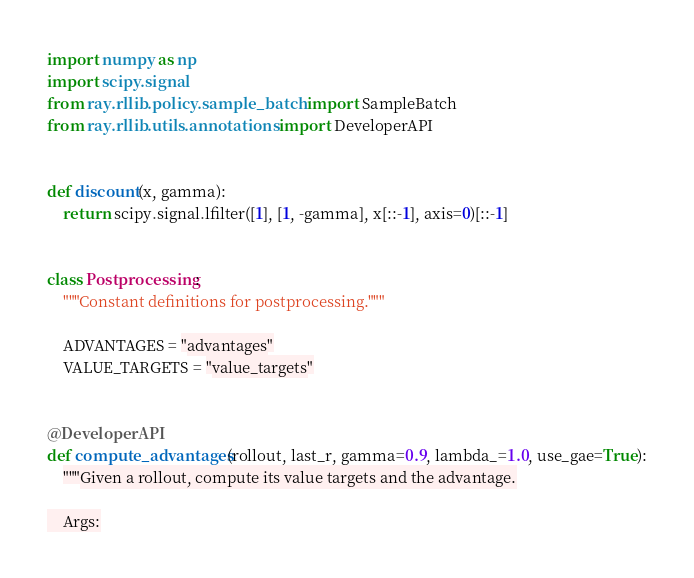<code> <loc_0><loc_0><loc_500><loc_500><_Python_>import numpy as np
import scipy.signal
from ray.rllib.policy.sample_batch import SampleBatch
from ray.rllib.utils.annotations import DeveloperAPI


def discount(x, gamma):
    return scipy.signal.lfilter([1], [1, -gamma], x[::-1], axis=0)[::-1]


class Postprocessing:
    """Constant definitions for postprocessing."""

    ADVANTAGES = "advantages"
    VALUE_TARGETS = "value_targets"


@DeveloperAPI
def compute_advantages(rollout, last_r, gamma=0.9, lambda_=1.0, use_gae=True):
    """Given a rollout, compute its value targets and the advantage.

    Args:</code> 